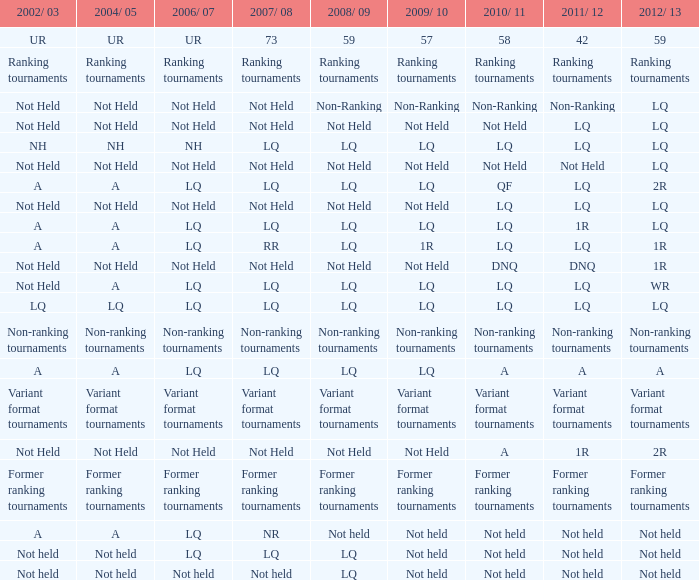Describe the conditions in 2011/12 and 2008/09 when events were not conducted, and compare them to the 2010/11 timeframe when events were not held as well. LQ, Not Held, Not held. 